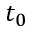Convert formula to latex. <formula><loc_0><loc_0><loc_500><loc_500>t _ { 0 }</formula> 